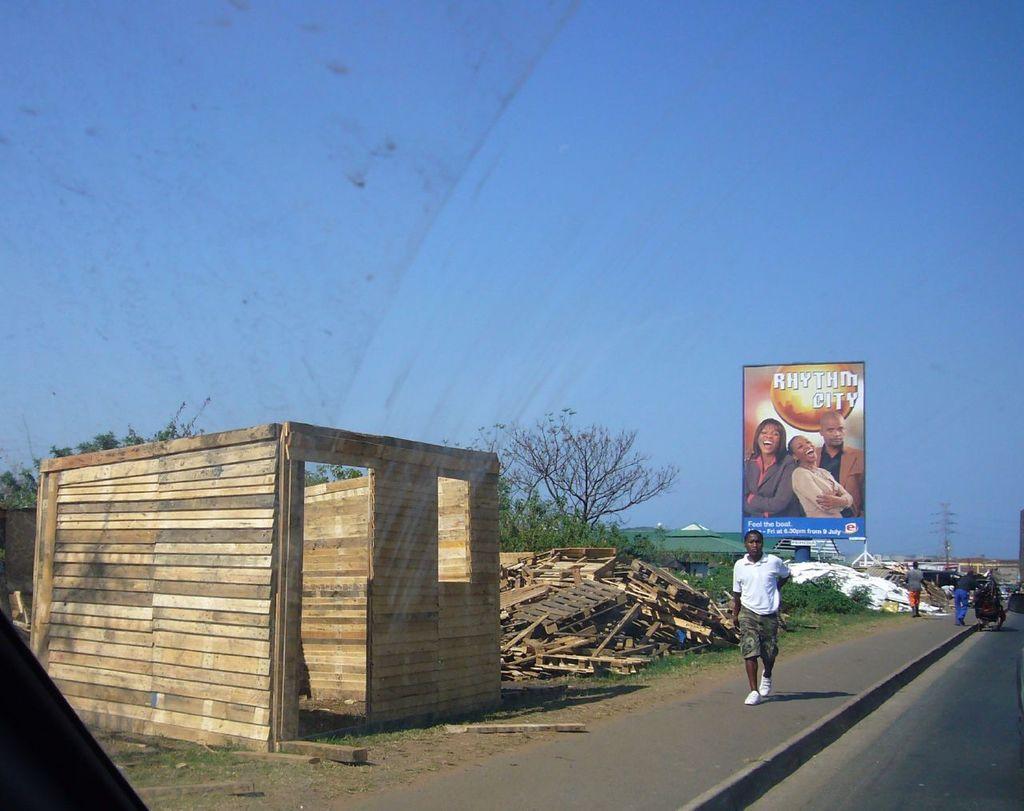Which city is featured on the street sign?
Your answer should be very brief. Rhythm. 